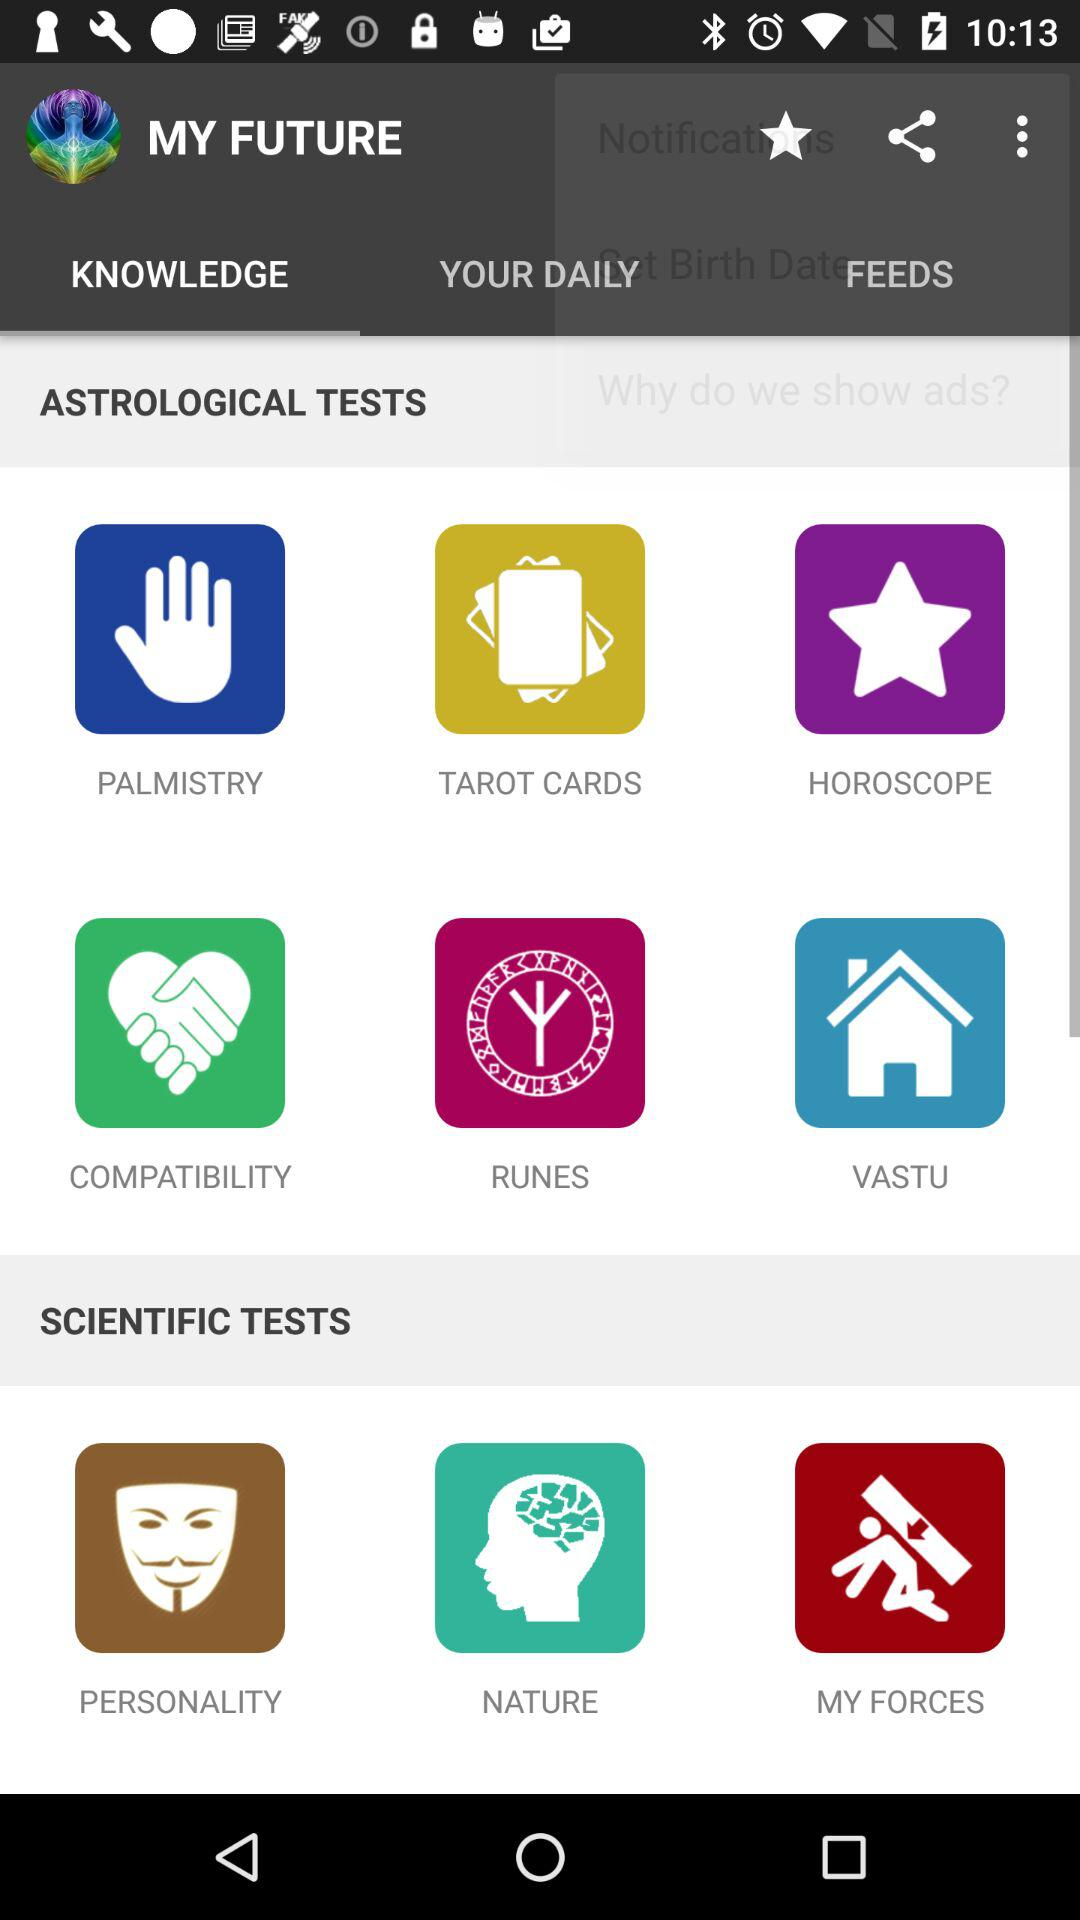Which tab is selected? The selected tab is Knowledge. 